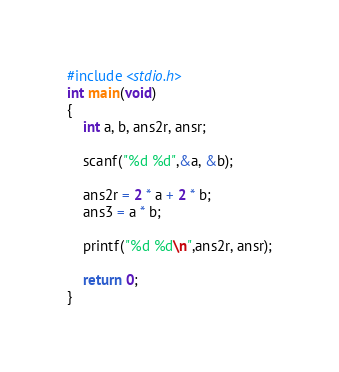Convert code to text. <code><loc_0><loc_0><loc_500><loc_500><_C_>#include <stdio.h>
int main(void)
{
	int a, b, ans2r, ansr;
	
	scanf("%d %d",&a, &b);
	
	ans2r = 2 * a + 2 * b;
	ans3 = a * b;
	
	printf("%d %d\n",ans2r, ansr);
	
	return 0;
}</code> 